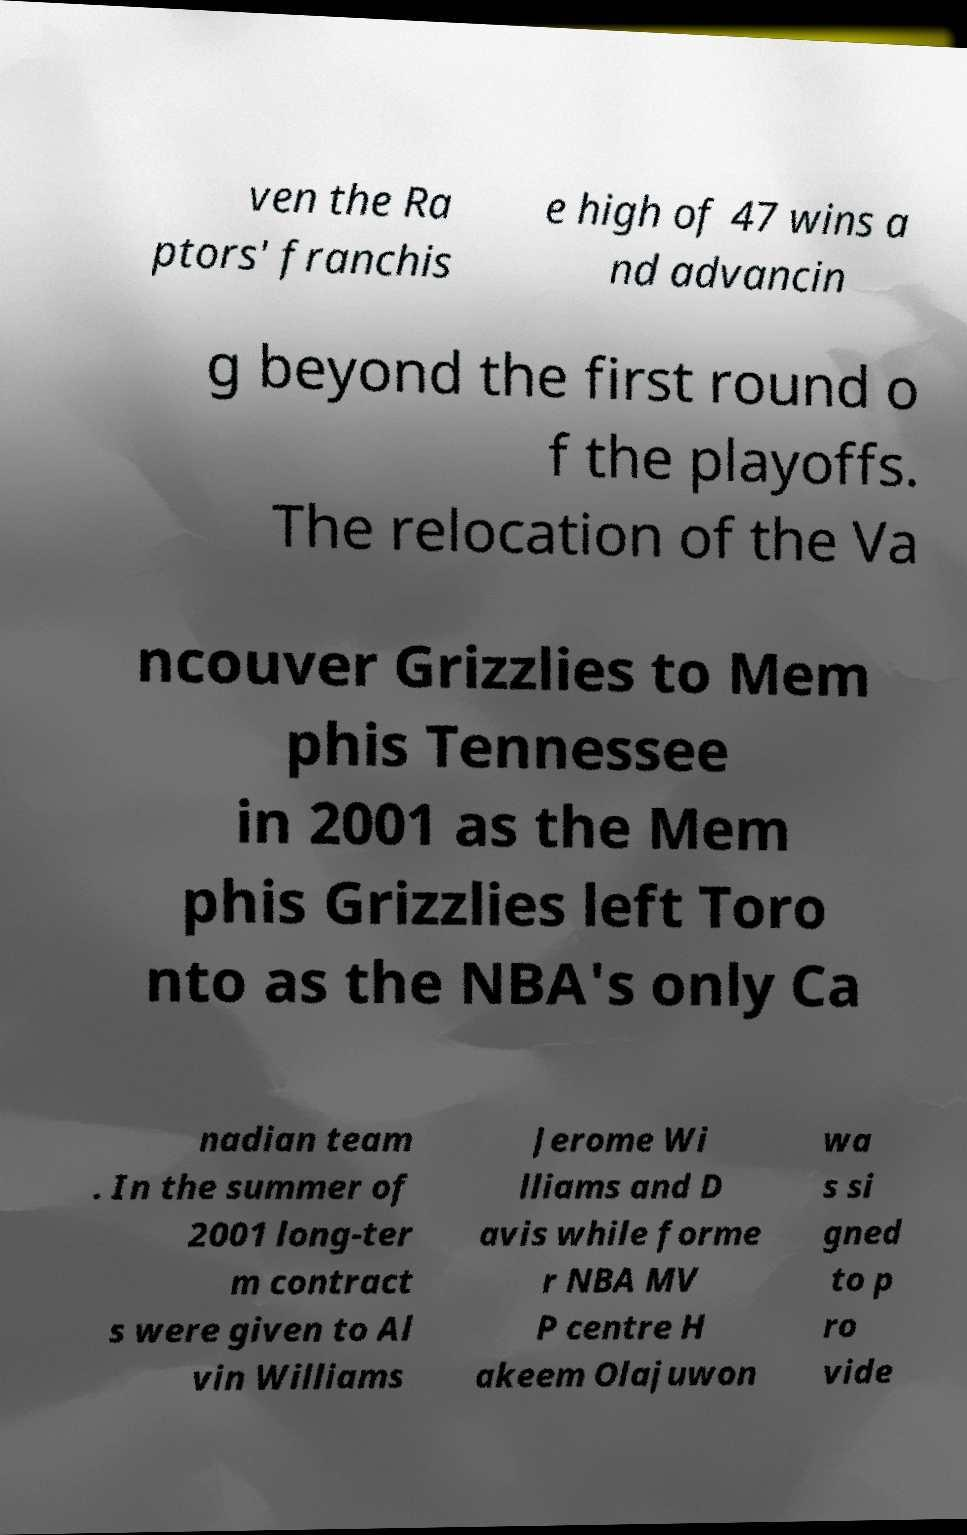Could you extract and type out the text from this image? ven the Ra ptors' franchis e high of 47 wins a nd advancin g beyond the first round o f the playoffs. The relocation of the Va ncouver Grizzlies to Mem phis Tennessee in 2001 as the Mem phis Grizzlies left Toro nto as the NBA's only Ca nadian team . In the summer of 2001 long-ter m contract s were given to Al vin Williams Jerome Wi lliams and D avis while forme r NBA MV P centre H akeem Olajuwon wa s si gned to p ro vide 